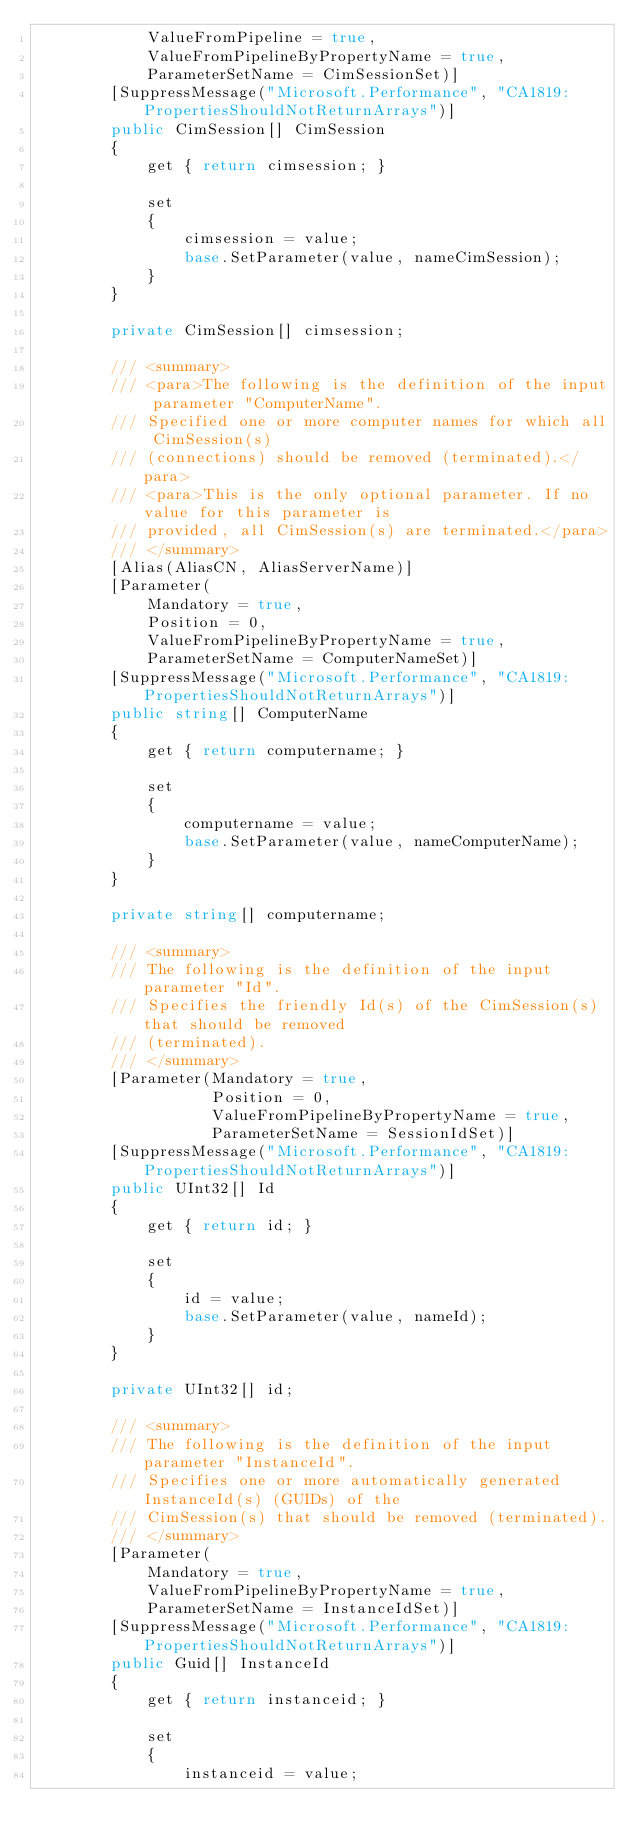<code> <loc_0><loc_0><loc_500><loc_500><_C#_>            ValueFromPipeline = true,
            ValueFromPipelineByPropertyName = true,
            ParameterSetName = CimSessionSet)]
        [SuppressMessage("Microsoft.Performance", "CA1819:PropertiesShouldNotReturnArrays")]
        public CimSession[] CimSession
        {
            get { return cimsession; }

            set
            {
                cimsession = value;
                base.SetParameter(value, nameCimSession);
            }
        }

        private CimSession[] cimsession;

        /// <summary>
        /// <para>The following is the definition of the input parameter "ComputerName".
        /// Specified one or more computer names for which all CimSession(s)
        /// (connections) should be removed (terminated).</para>
        /// <para>This is the only optional parameter. If no value for this parameter is
        /// provided, all CimSession(s) are terminated.</para>
        /// </summary>
        [Alias(AliasCN, AliasServerName)]
        [Parameter(
            Mandatory = true,
            Position = 0,
            ValueFromPipelineByPropertyName = true,
            ParameterSetName = ComputerNameSet)]
        [SuppressMessage("Microsoft.Performance", "CA1819:PropertiesShouldNotReturnArrays")]
        public string[] ComputerName
        {
            get { return computername; }

            set
            {
                computername = value;
                base.SetParameter(value, nameComputerName);
            }
        }

        private string[] computername;

        /// <summary>
        /// The following is the definition of the input parameter "Id".
        /// Specifies the friendly Id(s) of the CimSession(s) that should be removed
        /// (terminated).
        /// </summary>
        [Parameter(Mandatory = true,
                   Position = 0,
                   ValueFromPipelineByPropertyName = true,
                   ParameterSetName = SessionIdSet)]
        [SuppressMessage("Microsoft.Performance", "CA1819:PropertiesShouldNotReturnArrays")]
        public UInt32[] Id
        {
            get { return id; }

            set
            {
                id = value;
                base.SetParameter(value, nameId);
            }
        }

        private UInt32[] id;

        /// <summary>
        /// The following is the definition of the input parameter "InstanceId".
        /// Specifies one or more automatically generated InstanceId(s) (GUIDs) of the
        /// CimSession(s) that should be removed (terminated).
        /// </summary>
        [Parameter(
            Mandatory = true,
            ValueFromPipelineByPropertyName = true,
            ParameterSetName = InstanceIdSet)]
        [SuppressMessage("Microsoft.Performance", "CA1819:PropertiesShouldNotReturnArrays")]
        public Guid[] InstanceId
        {
            get { return instanceid; }

            set
            {
                instanceid = value;</code> 